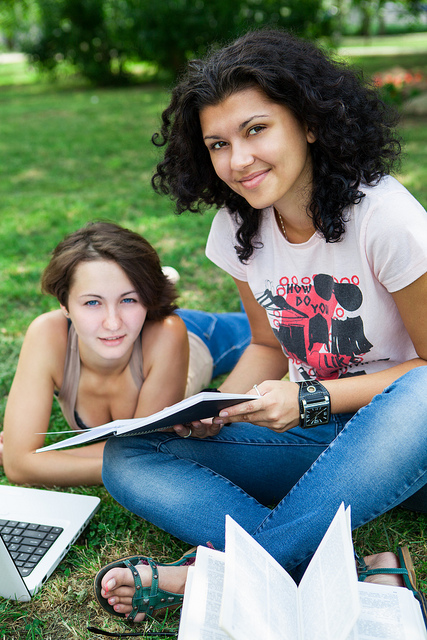Read and extract the text from this image. HOW DO YO E LIK 